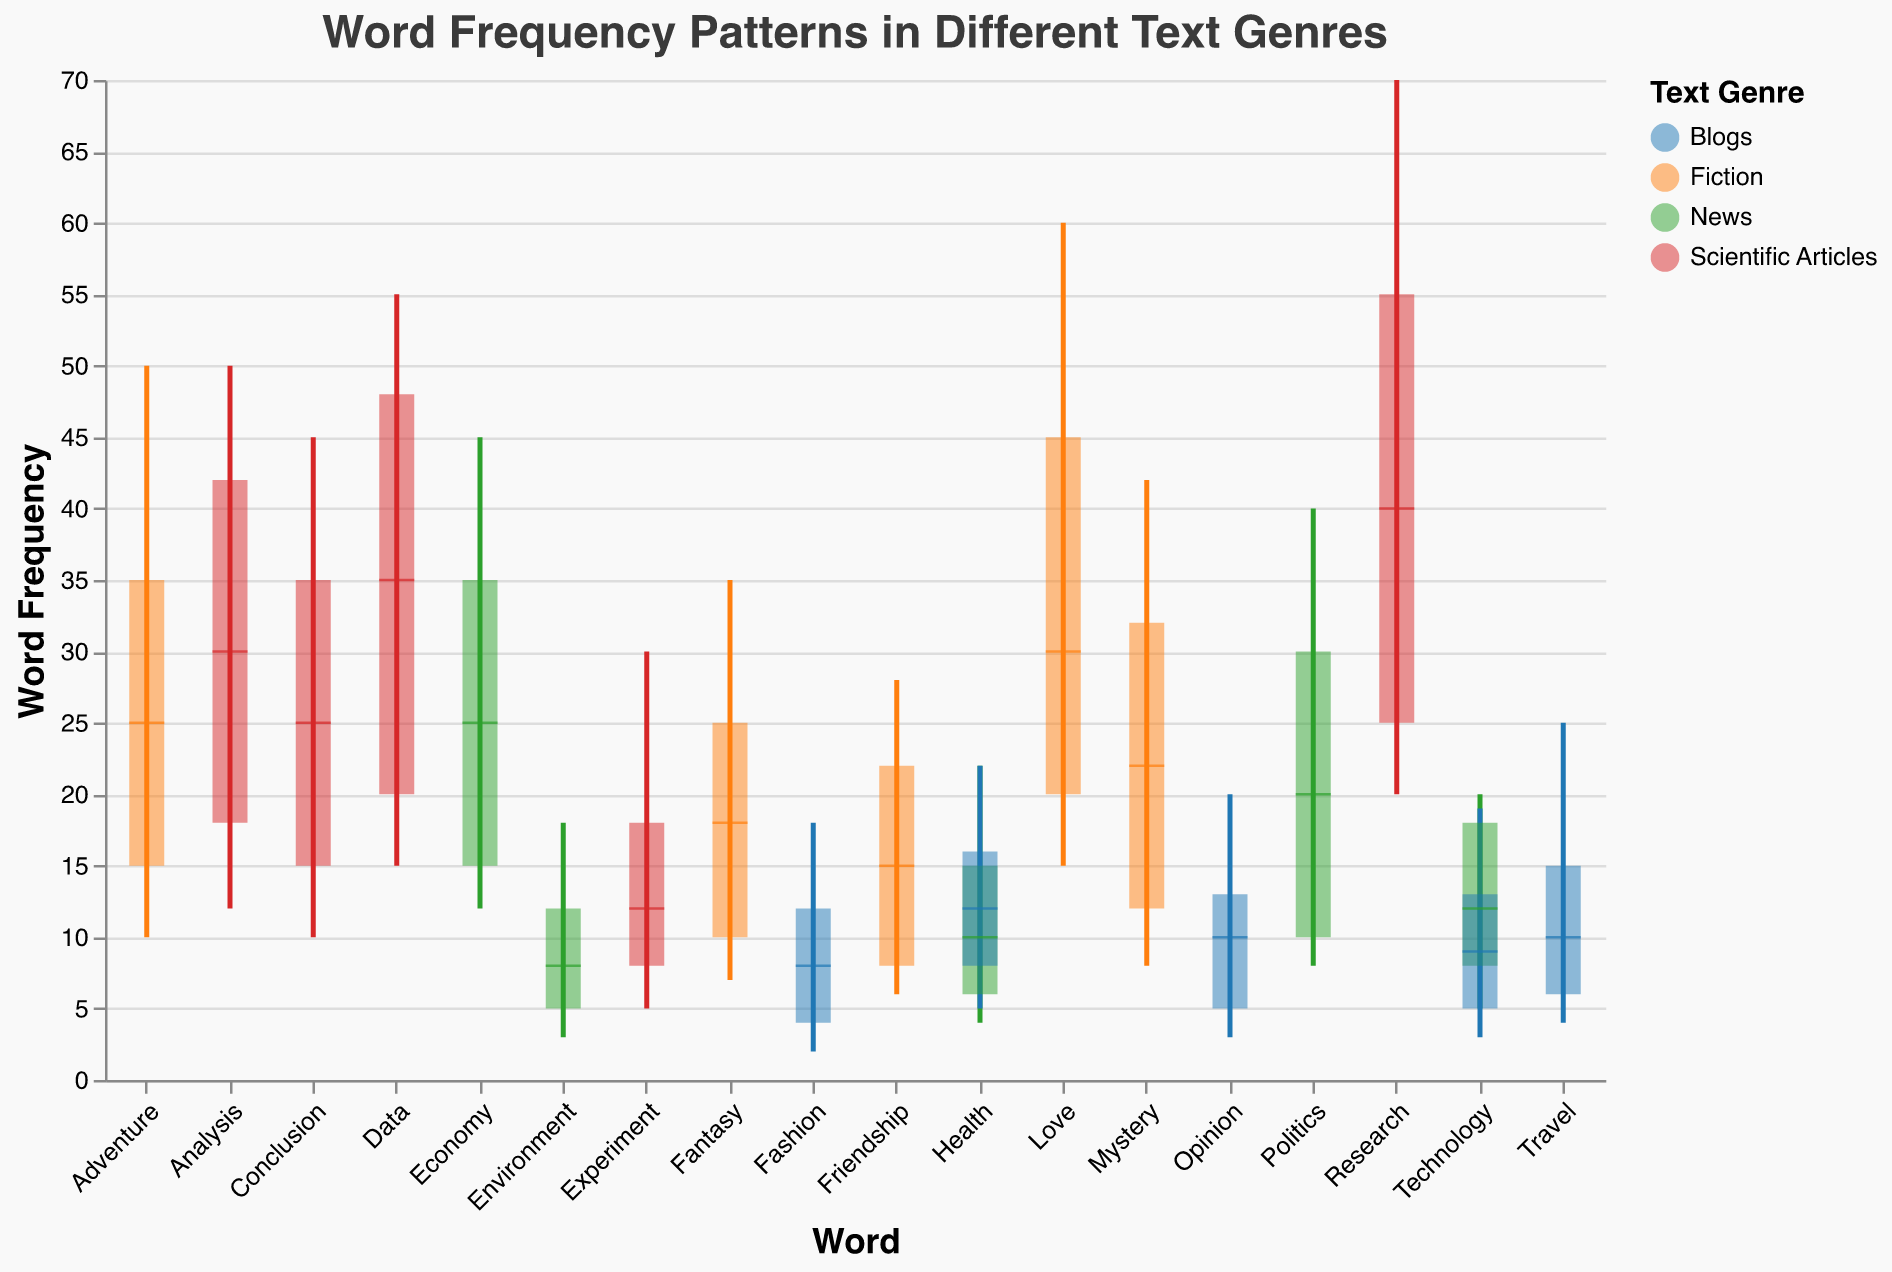What is the maximum word frequency for the word 'Research' in Scientific Articles? The maximum word frequency for 'Research' in Scientific Articles can be found at the top end of the candlestick.
Answer: 70 What is the median word frequency for 'Opinion' in Blogs? The median word frequency is marked by the black tick mark within the bar. For 'Opinion' in Blogs, this value is at the middle of the bar.
Answer: 10 Which word has the highest minimum frequency in the Fiction genre? By looking at the bottom end of the candlestick plots, we compare the minimum values for each word in the Fiction genre.
Answer: Love What is the interquartile range (IQR) for the word 'Technology' in the News genre? The interquartile range (IQR) is calculated by subtracting the first quartile value from the third quartile value. For 'Technology' in News, the third quartile is 18 and the first quartile is 8.
Answer: 10 How does the word frequency range of 'Health' in Blogs compare to that in News? By comparing the full range (Min to Max) of 'Health' between Blogs and News, we see that News ranges from 4 to 22 and Blogs ranges from 5 to 22.
Answer: News: 4-22, Blogs: 5-22 Which word has the widest frequency range in Scientific Articles? Widest range can be identified by the length of the lines (Min to Max) in the candlestick plots. In Scientific Articles, the word 'Research' has the largest difference between Min and Max values.
Answer: Research What are the first quartile and third quartile values for 'Adventure' in Fiction? The first quartile and third quartile values are indicated by the bottom and top of the bar respectively. For 'Adventure' in Fiction, these are 15 and 35.
Answer: 15 and 35 Is there any word in the Scientific Articles genre whose median word frequency equals 40? If yes, identify the word. By examining the black tick marks in the Scientific Articles plots, we identify if any word has its median frequency at 40. Yes, 'Research' has a median word frequency of 40.
Answer: Research 